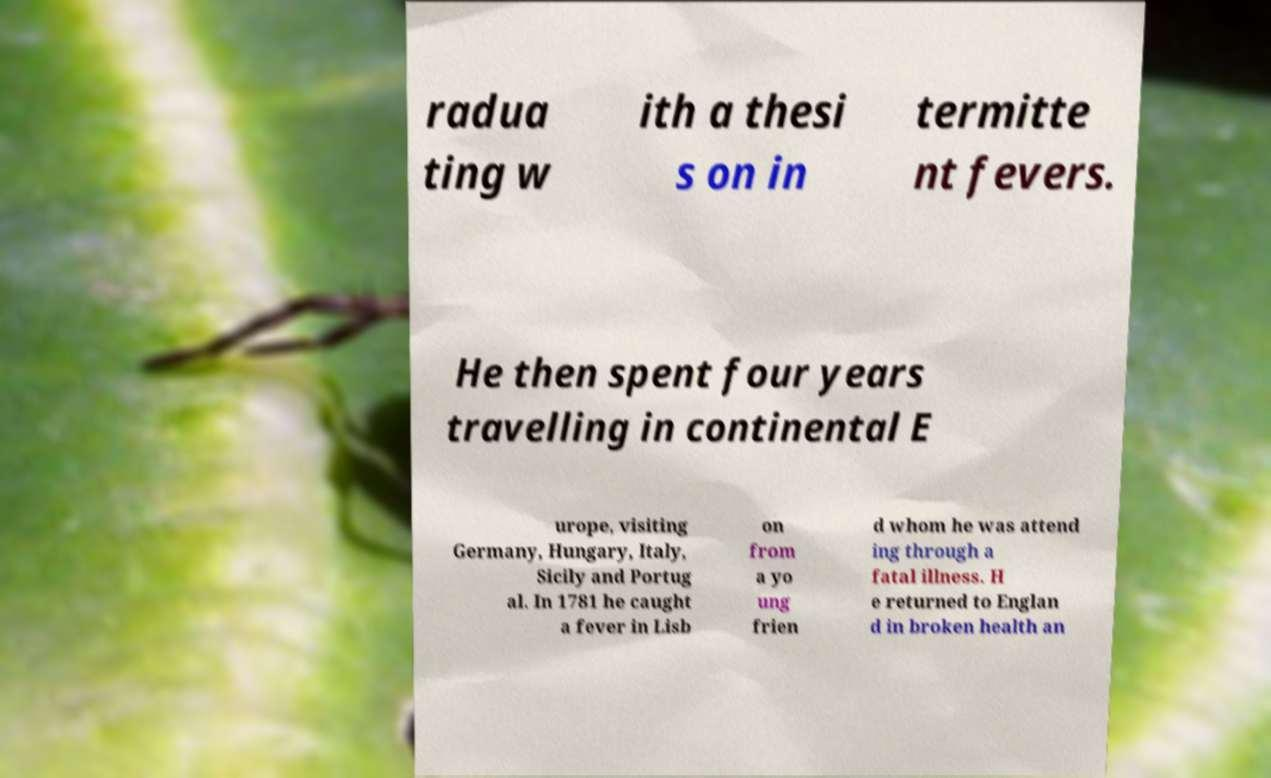Could you assist in decoding the text presented in this image and type it out clearly? radua ting w ith a thesi s on in termitte nt fevers. He then spent four years travelling in continental E urope, visiting Germany, Hungary, Italy, Sicily and Portug al. In 1781 he caught a fever in Lisb on from a yo ung frien d whom he was attend ing through a fatal illness. H e returned to Englan d in broken health an 